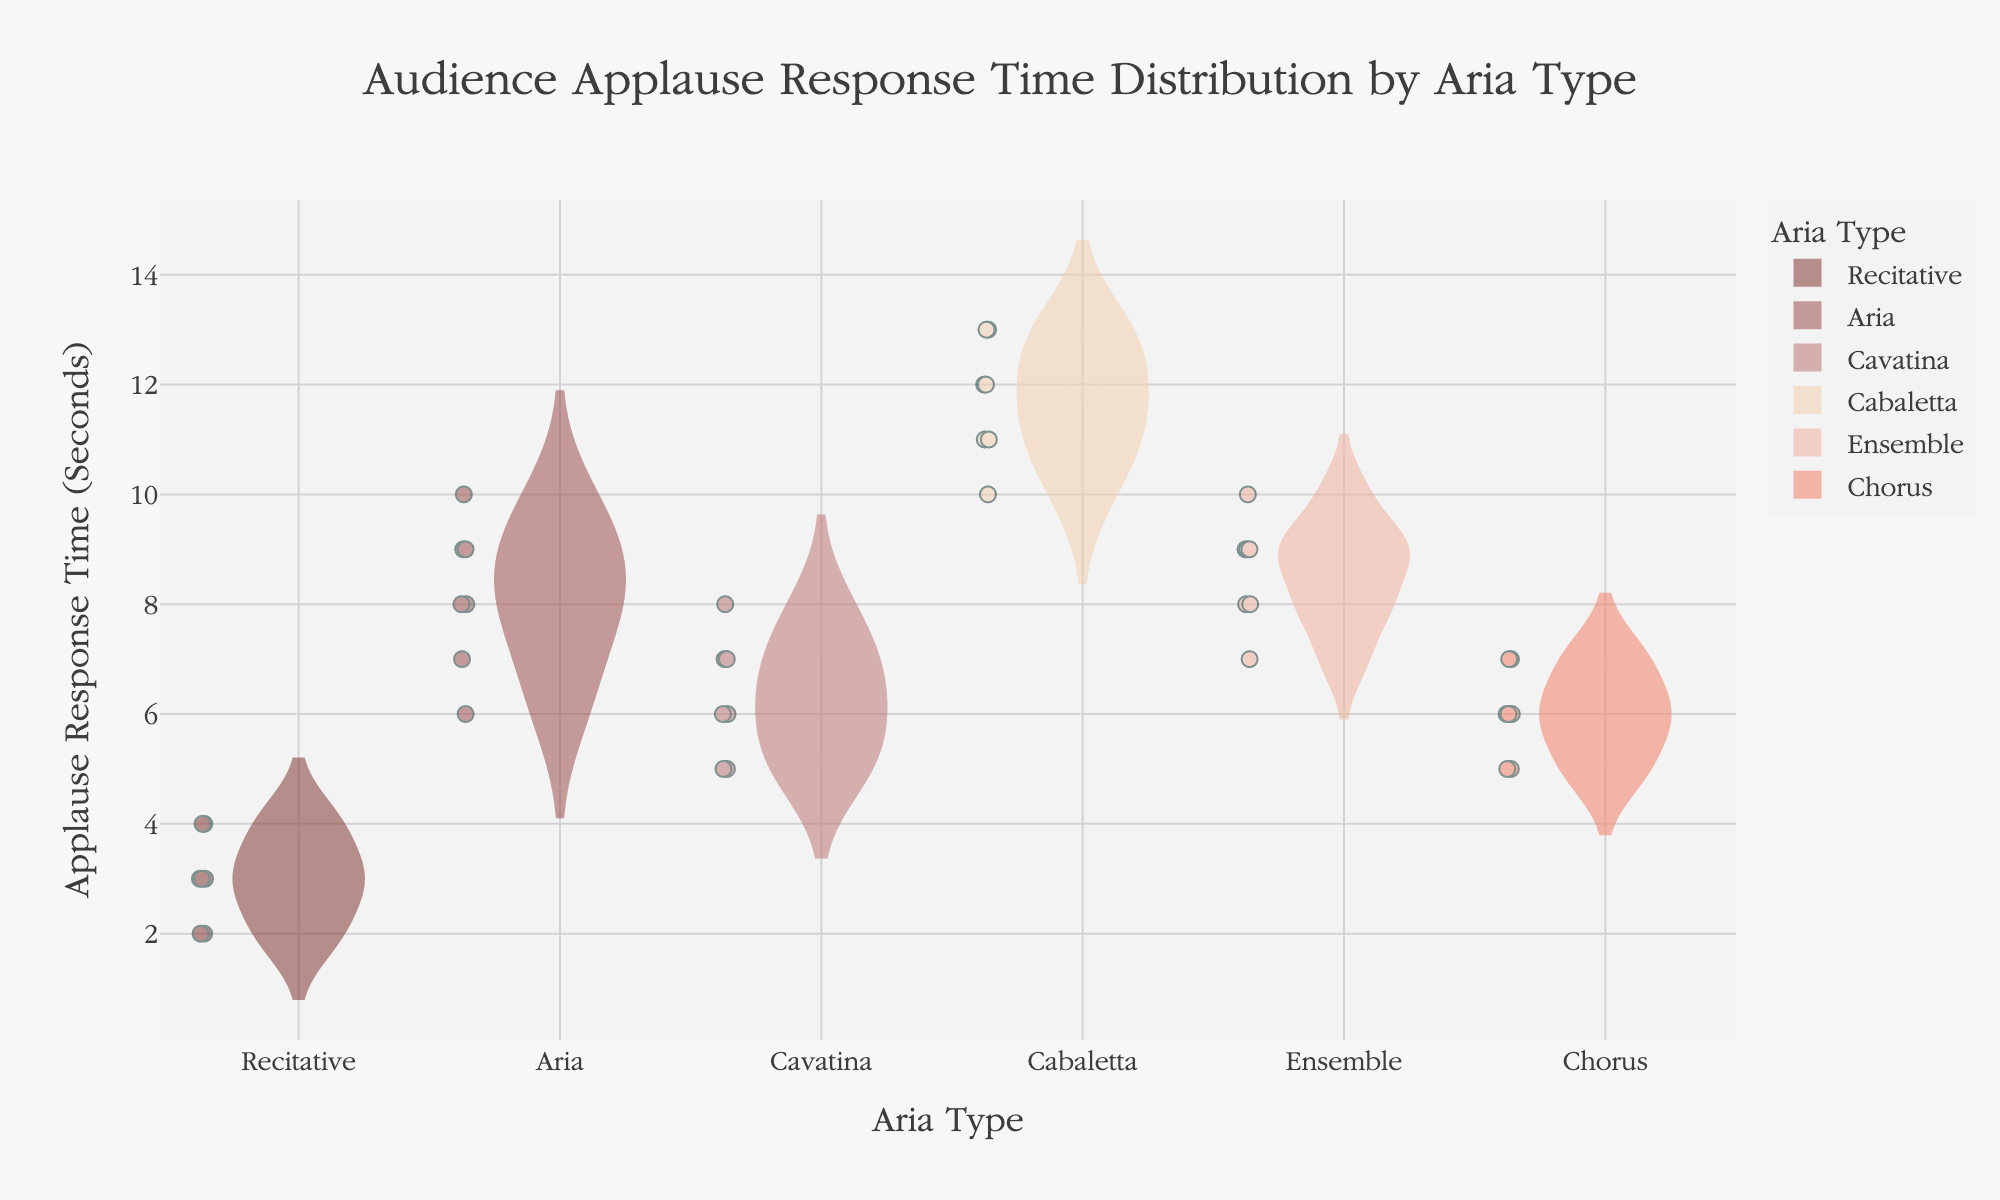What is the title of the figure? The title of the figure is typically displayed prominently at the top and provides a summary of the content. In this case, the title is "Audience Applause Response Time Distribution by Aria Type".
Answer: Audience Applause Response Time Distribution by Aria Type Which aria type has the longest median applause response time? To find the longest median applause response time, refer to the central line in the box plot overlay for each aria type on the violin chart. The highest median line represents the longest median applause response time.
Answer: Cabaletta What are the minimum and maximum applause response times for the "Aria" type? The minimum and maximum values are shown as the lower and upper bounds of the box plots. For the "Aria" type, observe these bounds in the respective violin plot.
Answer: Minimum: 6, Maximum: 10 Compare the mean applause response times between "Cavatina" and "Ensemble" arias. Which is higher? The mean response time is indicated by the mean line within each violin plot. By comparing these lines for "Cavatina" and "Ensemble", you can determine which one is higher.
Answer: Ensemble Which aria type shows the widest distribution of applause response times? The width of each violin plot indicates the distribution. The aria type with the widest violin plot has the highest variability in response times.
Answer: Cabaletta What is the range of applause response times for "Chorus" arias? The range is determined by the difference between the maximum and minimum applause response times in the box plot of the "Chorus" aria.
Answer: 2 seconds (5 to 7 seconds) Between "Recitative" and "Aria", which aria type has a smaller interquartile range? The interquartile range (IQR) is the range between the first quartile (Q1) and the third quartile (Q3) in the box plot. Compare these ranges for "Recitative" and "Aria".
Answer: Recitative How many data points are represented in the "Cabaletta" aria section? The number of data points is illustrated by the dots in the violin plot. Count these points for the "Cabaletta" aria.
Answer: 7 For which aria type do the majority of applause response times fall between 5 and 7 seconds? Observing the density within the violin plot will show where most of the data points lie. The aria type with the highest density between 5 and 7 seconds is what is sought.
Answer: Chorus Which two aria types have overlapping response time distributions? Examine the violin plots for overlap in their response time ranges. Identify the two aria types that share common response time ranges.
Answer: Aria and Ensemble 